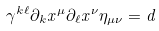<formula> <loc_0><loc_0><loc_500><loc_500>\gamma ^ { k \ell } \partial _ { k } x ^ { \mu } \partial _ { \ell } x ^ { \nu } \eta _ { \mu \nu } = d</formula> 